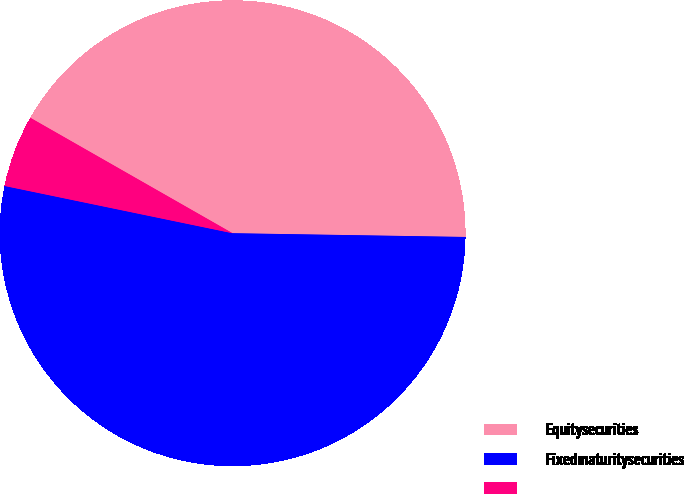Convert chart to OTSL. <chart><loc_0><loc_0><loc_500><loc_500><pie_chart><fcel>Equitysecurities<fcel>Fixedmaturitysecurities<fcel>Unnamed: 2<nl><fcel>42.0%<fcel>53.0%<fcel>5.0%<nl></chart> 